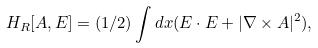<formula> <loc_0><loc_0><loc_500><loc_500>H _ { R } [ A , E ] = ( 1 / 2 ) \int d x ( E \cdot E + | \nabla \times A | ^ { 2 } ) ,</formula> 